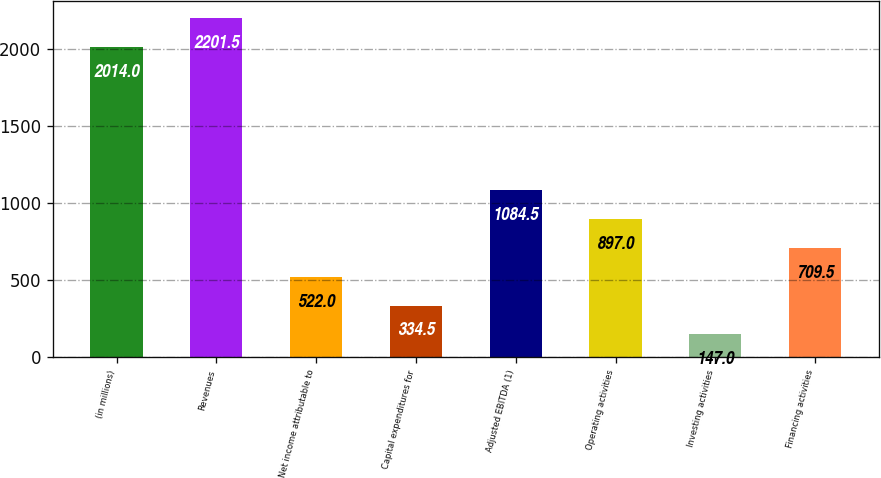Convert chart. <chart><loc_0><loc_0><loc_500><loc_500><bar_chart><fcel>(in millions)<fcel>Revenues<fcel>Net income attributable to<fcel>Capital expenditures for<fcel>Adjusted EBITDA (1)<fcel>Operating activities<fcel>Investing activities<fcel>Financing activities<nl><fcel>2014<fcel>2201.5<fcel>522<fcel>334.5<fcel>1084.5<fcel>897<fcel>147<fcel>709.5<nl></chart> 